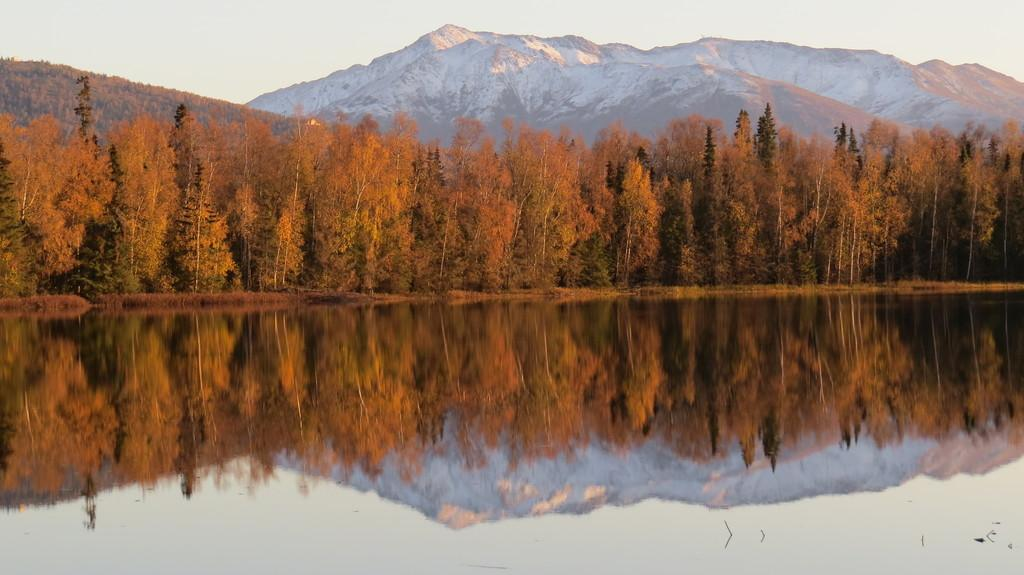What is the primary element present in the image? There is water in the image. What type of natural vegetation can be seen in the image? There are trees in the image. What type of geographical feature is visible in the distance? There are snow-covered mountains in the image. What can be seen in the background of the image? The sky is visible in the background of the image. What type of pie is being served at the border in the image? There is no pie or border present in the image. 